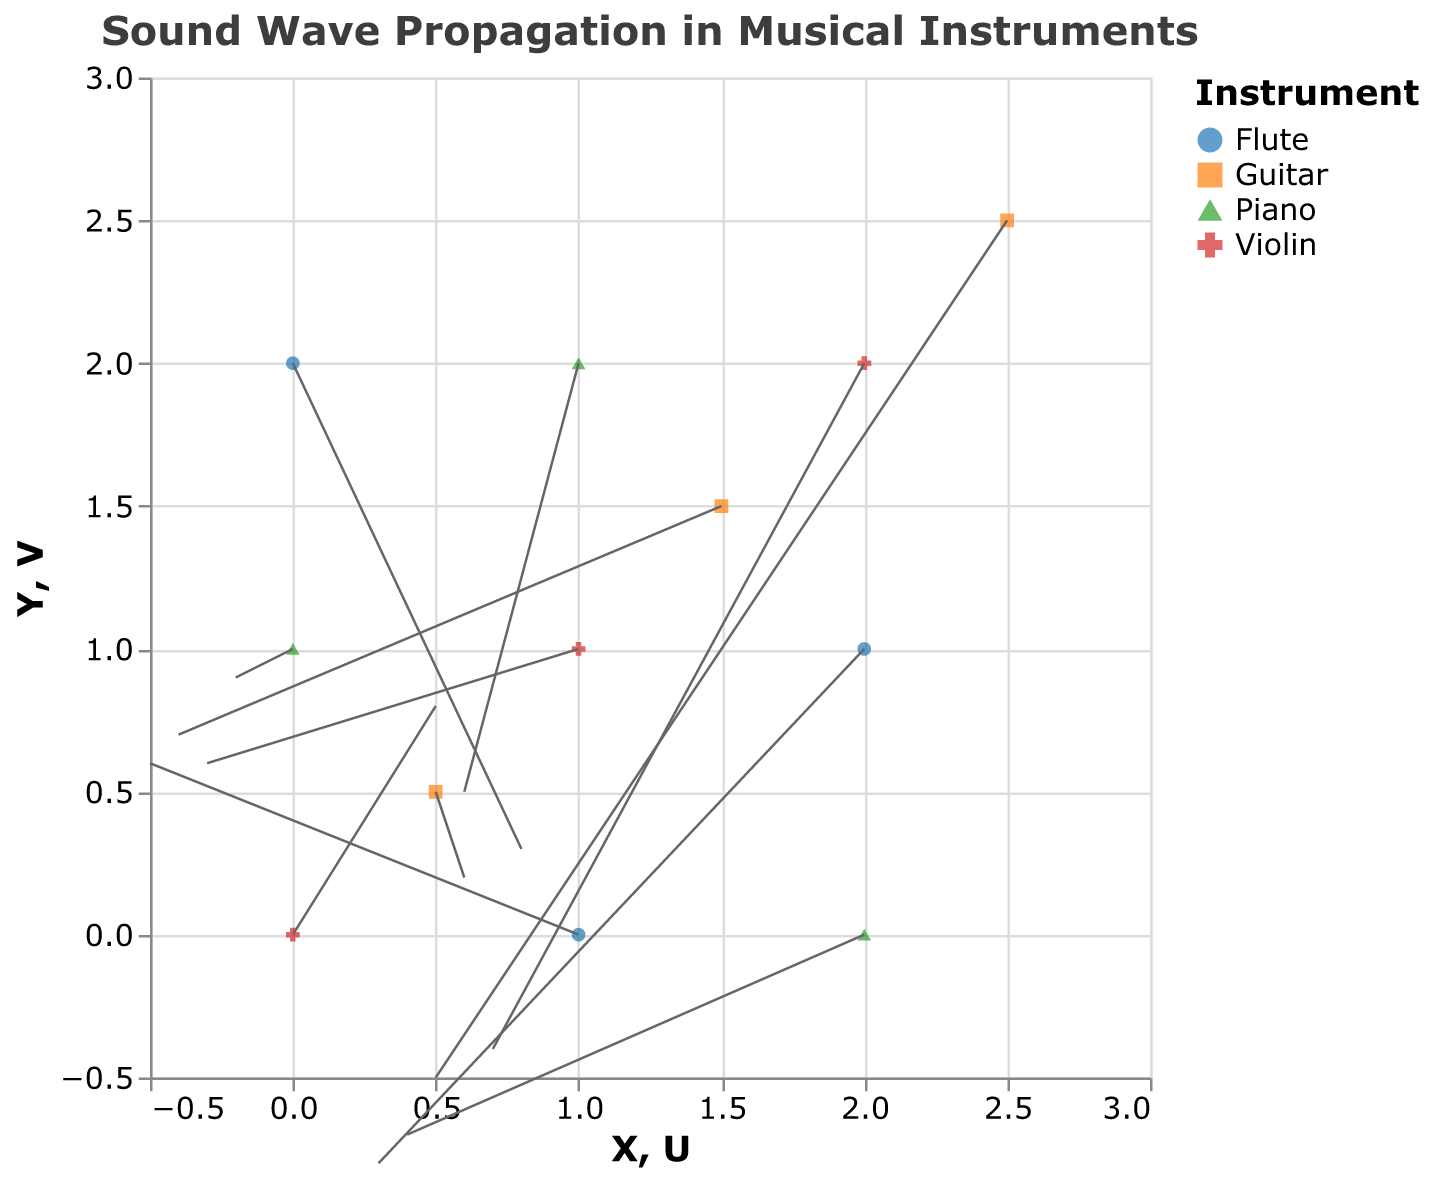What is the title of the figure? The title can be found at the top of the figure in a larger and bolder font than the rest of the text in the figure. In this case, it is "Sound Wave Propagation in Musical Instruments."
Answer: Sound Wave Propagation in Musical Instruments What are the four musical instruments represented in the figure? The figure uses different colors and shapes to represent different musical instruments, which can be seen in the legend. The four instruments are Violin, Piano, Flute, and Guitar.
Answer: Violin, Piano, Flute, Guitar Which instrument has a data point at coordinates (0.5, 0.5)? By looking at the coordinates (0.5, 0.5) on the plot and matching it with the color and shape in the legend, we can determine that this point represents the Guitar.
Answer: Guitar What is the displacement vector (U, V) for the Piano at coordinates (1, 2)? The displacement vector (U, V) is given by the specific values associated with the Piano at coordinates (1, 2) in the data table or by looking at the plot directly. It is (0.6, 0.5).
Answer: (0.6, 0.5) Compare the direction of the sound wave propagation vectors for Violins at (0,0) and (1,1). For the Violin at (0,0), the vector is (0.5, 0.8). For the Violin at (1,1), the vector is (-0.3, 0.6). The direction can be compared by analyzing these vectors. The first one points upwards and to the right, whereas the second one points upwards and to the left.
Answer: The first vector points upwards and to the right; the second vector points upwards and to the left Which musical instrument has the longest vector in the plot? To determine the longest vector, calculate the magnitude of each vector (sqrt(U^2 + V^2)) and compare them. The vector for Piano at (0,1) with U=-0.2 and V=0.9 results in the longest magnitude, which is approximately 0.922.
Answer: Piano Is the direction of sound wave propagation in the Guitar consistent across all its data points? To verify if the direction is consistent, look at the vectors of the Guitar at all coordinates. The vectors for the Guitar at (0.5, 0.5), (1.5, 1.5), and (2.5, 2.5) are (0.6, 0.2), (-0.4, 0.7), and (0.5, -0.5), indicating varied directions.
Answer: No What is the average magnitude of the displacement vectors for the Flute? Calculate the magnitudes of the vectors for the Flute at coordinates (0,2), (1,0), and (2,1), sum them, and then divide by the number of vectors. Magnitudes: sqrt(0.8^2 + 0.3^2) = 0.854, sqrt((-0.5)^2 + 0.6^2) = 0.781, sqrt(0.3^2 + (-0.8)^2) = 0.854. The average is (0.854 + 0.781 + 0.854) / 3 = 0.83.
Answer: 0.83 Which instrument has the most data points on the plot? By counting the number of points represented for each instrument, we can determine that the Violin, Piano, and Flute each have 3 points. Guitar also has 3 points. Hence, no instrument has more data points than the others.
Answer: All instruments have the same number of data points 